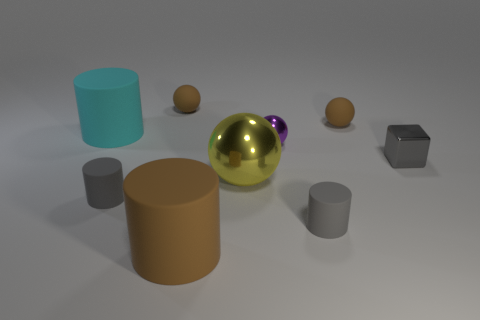What color is the large cylinder right of the tiny cylinder that is to the left of the large brown rubber thing?
Give a very brief answer. Brown. Does the large brown thing have the same shape as the small purple thing?
Ensure brevity in your answer.  No. What is the material of the big object that is the same shape as the tiny purple metal object?
Offer a terse response. Metal. There is a cylinder that is to the right of the tiny metal thing to the left of the small gray cube; is there a sphere in front of it?
Give a very brief answer. No. There is a cyan rubber object; is it the same shape as the brown matte thing that is to the right of the big brown object?
Provide a succinct answer. No. Are there any other things that are the same color as the shiny block?
Your answer should be very brief. Yes. There is a large metal ball that is in front of the small purple thing; is its color the same as the cylinder behind the yellow object?
Ensure brevity in your answer.  No. Are any red metal cylinders visible?
Provide a short and direct response. No. Is there a large thing made of the same material as the small purple thing?
Offer a terse response. Yes. Is there any other thing that has the same material as the yellow sphere?
Your answer should be very brief. Yes. 